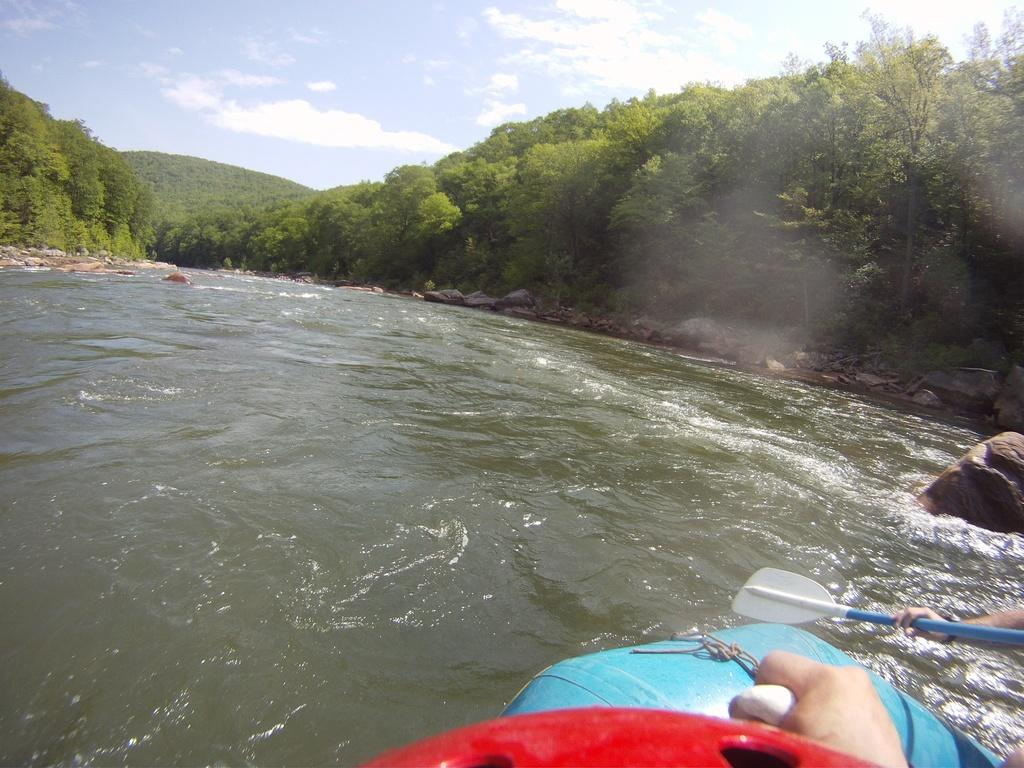What is the main subject of the image? There is an object on water in the image. What else can be seen in the image besides the object on water? There are stones visible in the image. What is the person in the image doing? A person's hand is holding a pedal. What can be seen in the background of the image? There are trees and the sky visible in the background of the image. What type of calendar is hanging on the tree in the image? There is no calendar present in the image; it only features an object on water, stones, a person's hand holding a pedal, trees, and the sky in the background. 